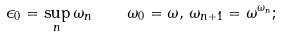Convert formula to latex. <formula><loc_0><loc_0><loc_500><loc_500>\epsilon _ { 0 } = \sup _ { n } \omega _ { n } \quad \omega _ { 0 } = \omega , \, \omega _ { n + 1 } = \omega ^ { \omega _ { n } } ;</formula> 